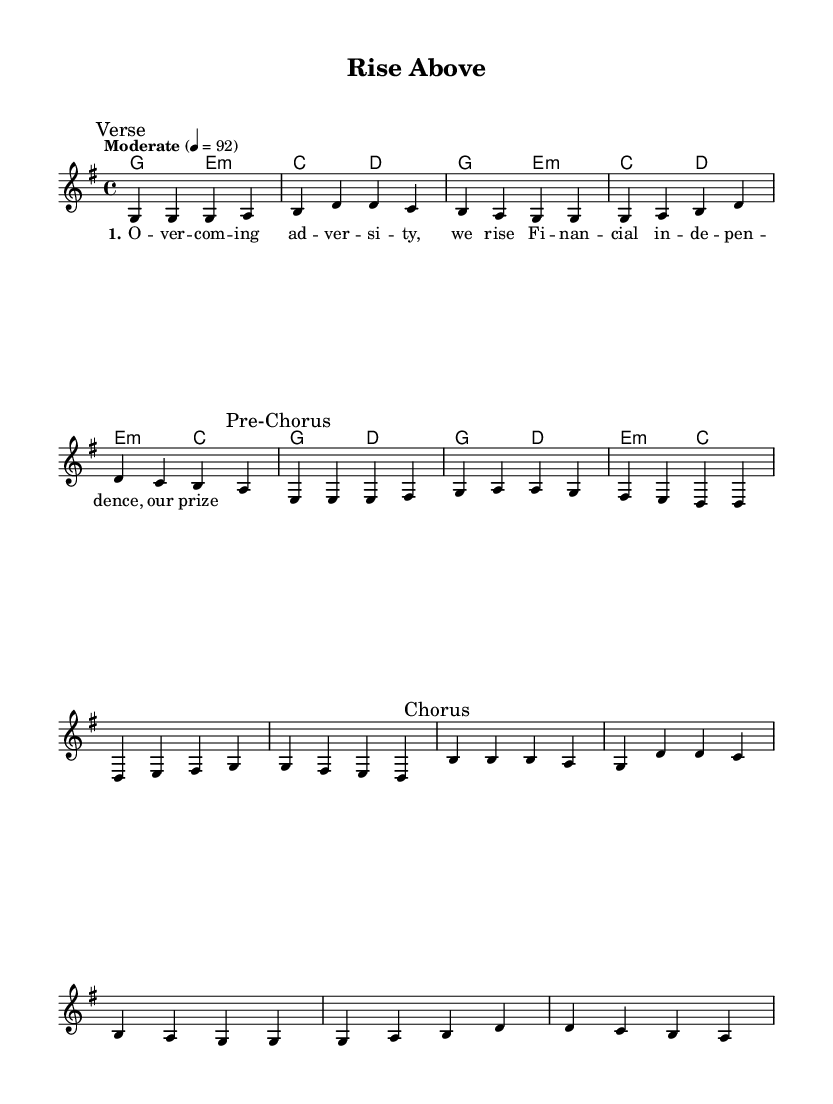What is the key signature of this music? The key signature is G major, which has one sharp (F#). It can be identified by looking at the key signature indicated at the beginning of the score.
Answer: G major What is the time signature of this music? The time signature is 4/4, which means there are four beats in each measure and the quarter note gets one beat. This is indicated near the beginning of the score.
Answer: 4/4 What is the tempo marking for this piece? The tempo marking is "Moderate" 4 = 92. This tells us the piece is to be played at a moderate speed, with 92 beats per minute. This information is found in the tempo directive at the beginning of the score.
Answer: Moderate 4 = 92 How many measures are there in the chorus section? The chorus consists of four measures, as indicated by the bars in the score during the "Chorus" mark. Each measure stretches from one vertical line to the next.
Answer: 4 In which section does the melody start with the note 'g'? The melody starts with the note 'g' in the Verse section. By locating the first note in the score, we see that it is indeed 'g' right under the "Verse" marking.
Answer: Verse What type of song structure does this piece primarily utilize? This piece utilizes a verse-chorus structure, a common form in romantic soft rock anthems where verses alternate with a catchy, memorable chorus. The divisions labeled "Verse," "Pre-Chorus," and "Chorus" illustrate this structure clearly.
Answer: Verse-Chorus 